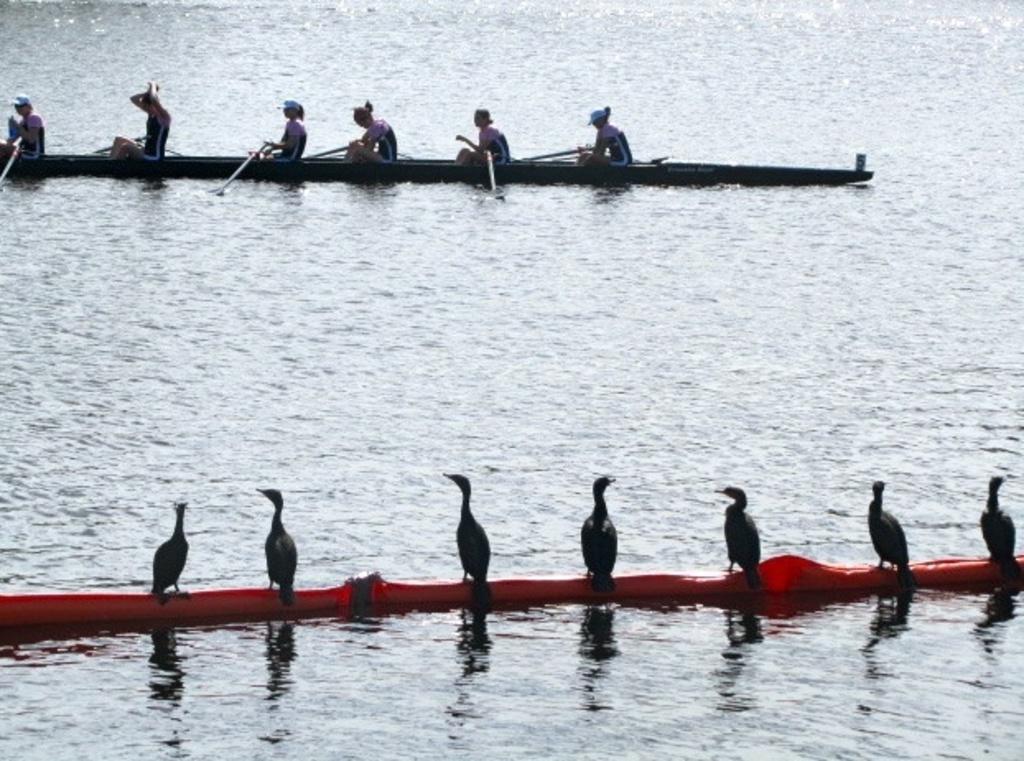How would you summarize this image in a sentence or two? This picture is clicked outside. In the foreground we can see the birds are standing on an object which is in the water body. In the background we can see the group of people seems to be rowing a canoe. 